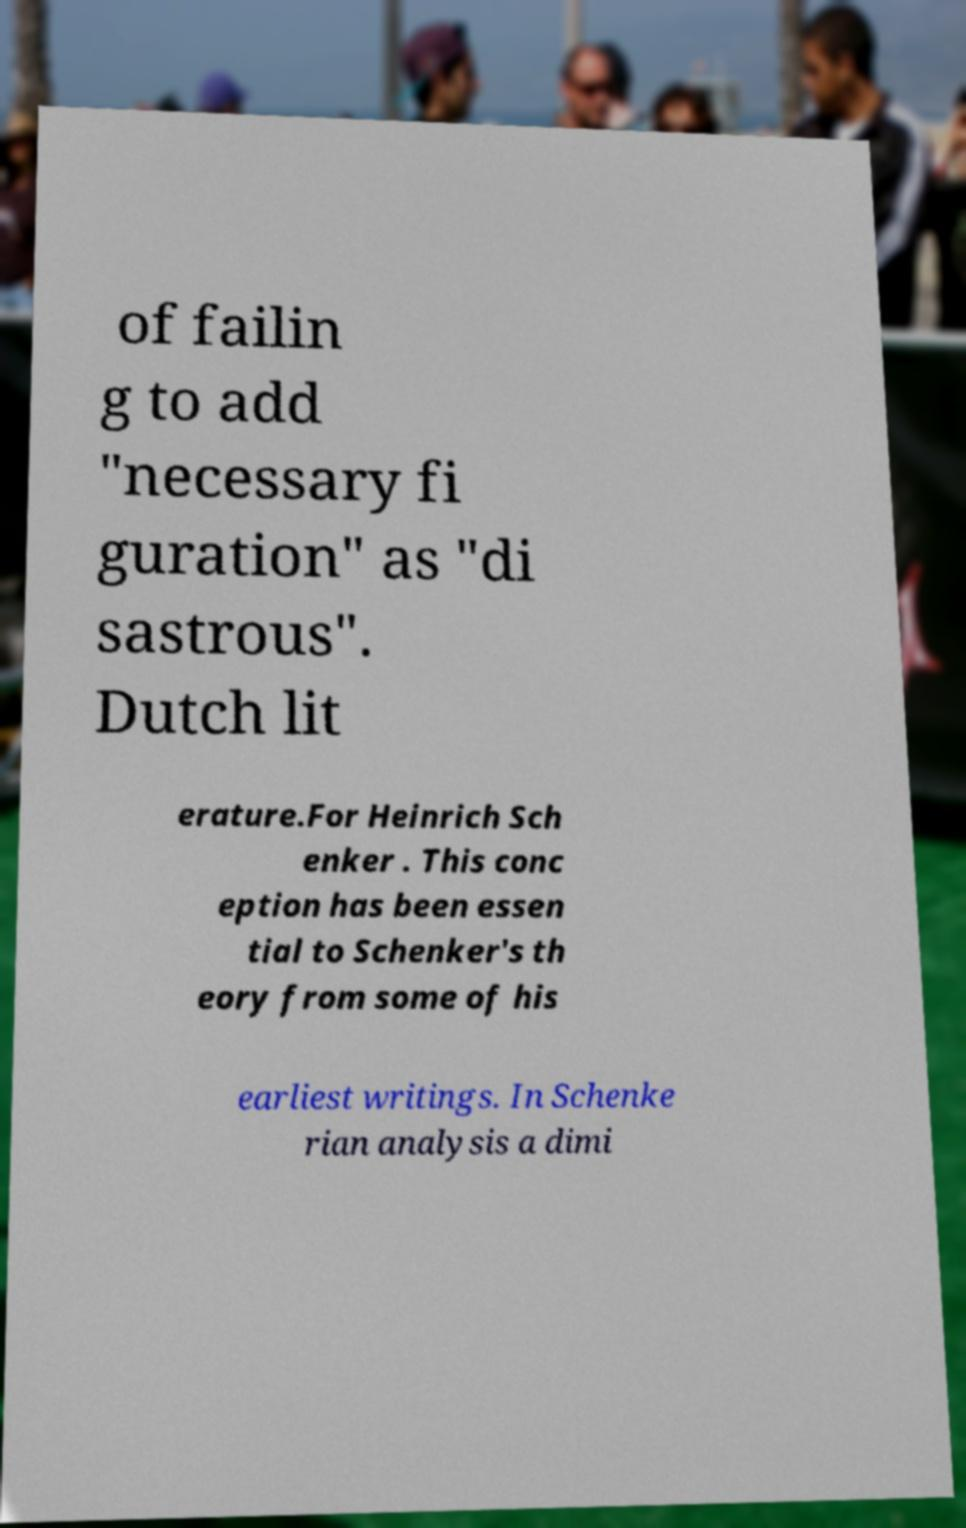For documentation purposes, I need the text within this image transcribed. Could you provide that? of failin g to add "necessary fi guration" as "di sastrous". Dutch lit erature.For Heinrich Sch enker . This conc eption has been essen tial to Schenker's th eory from some of his earliest writings. In Schenke rian analysis a dimi 